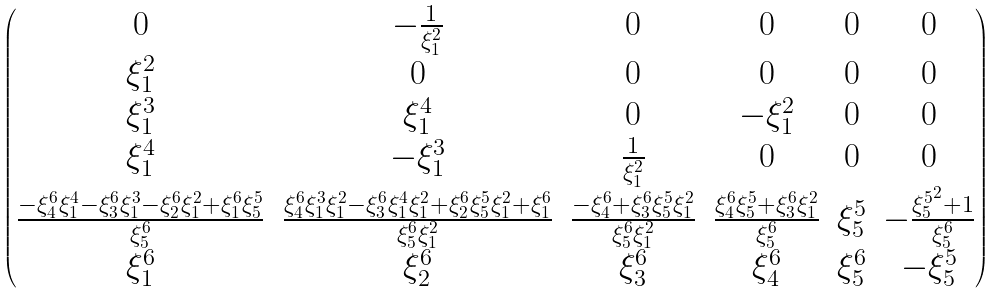Convert formula to latex. <formula><loc_0><loc_0><loc_500><loc_500>\begin{pmatrix} 0 & - \frac { 1 } { \xi ^ { 2 } _ { 1 } } & 0 & 0 & 0 & 0 \\ { \xi ^ { 2 } _ { 1 } } & 0 & 0 & 0 & 0 & 0 \\ { \xi ^ { 3 } _ { 1 } } & { \xi ^ { 4 } _ { 1 } } & 0 & - { \xi ^ { 2 } _ { 1 } } & 0 & 0 \\ { \xi ^ { 4 } _ { 1 } } & - { \xi ^ { 3 } _ { 1 } } & \frac { 1 } { \xi ^ { 2 } _ { 1 } } & 0 & 0 & 0 \\ \frac { - { \xi ^ { 6 } _ { 4 } } { \xi ^ { 4 } _ { 1 } } - { \xi ^ { 6 } _ { 3 } } { \xi ^ { 3 } _ { 1 } } - { \xi ^ { 6 } _ { 2 } } { \xi ^ { 2 } _ { 1 } } + { \xi ^ { 6 } _ { 1 } } { \xi ^ { 5 } _ { 5 } } } { \xi ^ { 6 } _ { 5 } } & \frac { { \xi ^ { 6 } _ { 4 } } { \xi ^ { 3 } _ { 1 } } { \xi ^ { 2 } _ { 1 } } - { \xi ^ { 6 } _ { 3 } } { \xi ^ { 4 } _ { 1 } } { \xi ^ { 2 } _ { 1 } } + { \xi ^ { 6 } _ { 2 } } { \xi ^ { 5 } _ { 5 } } { \xi ^ { 2 } _ { 1 } } + { \xi ^ { 6 } _ { 1 } } } { { \xi ^ { 6 } _ { 5 } } { \xi ^ { 2 } _ { 1 } } } & \frac { - { \xi ^ { 6 } _ { 4 } } + { \xi ^ { 6 } _ { 3 } } { \xi ^ { 5 } _ { 5 } } { \xi ^ { 2 } _ { 1 } } } { { \xi ^ { 6 } _ { 5 } } { \xi ^ { 2 } _ { 1 } } } & \frac { { \xi ^ { 6 } _ { 4 } } { \xi ^ { 5 } _ { 5 } } + { \xi ^ { 6 } _ { 3 } } { \xi ^ { 2 } _ { 1 } } } { \xi ^ { 6 } _ { 5 } } & { \xi ^ { 5 } _ { 5 } } & - \frac { { \xi ^ { 5 } _ { 5 } } ^ { 2 } + 1 } { \xi ^ { 6 } _ { 5 } } \\ { \xi ^ { 6 } _ { 1 } } & { \xi ^ { 6 } _ { 2 } } & { \xi ^ { 6 } _ { 3 } } & { \xi ^ { 6 } _ { 4 } } & { \xi ^ { 6 } _ { 5 } } & - { \xi ^ { 5 } _ { 5 } } \end{pmatrix}</formula> 